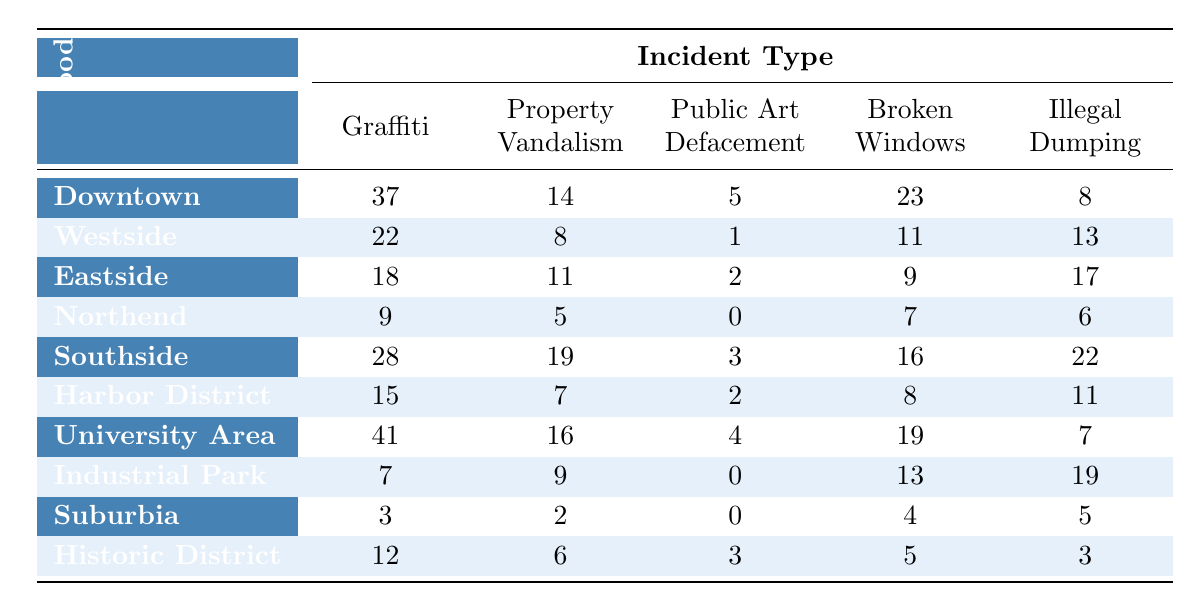What neighborhood reported the highest number of graffiti incidents? According to the table, the University Area has the highest count of graffiti incidents at 41.
Answer: 41 Which neighborhood had the fewest incidents of public art defacement? The Northend and Suburbia both reported 0 incidents of public art defacement, indicating the fewest.
Answer: Northend and Suburbia How many total incidents of property vandalism were reported in the Southside? The Southside reported 19 incidents of property vandalism as shown directly in the table.
Answer: 19 What is the total number of broken windows incidents reported across all neighborhoods? To find the total broken windows incidents, we add up the numbers from each neighborhood: 23 + 11 + 9 + 7 + 16 + 8 + 19 + 13 + 4 + 5 = 111
Answer: 111 Did the University Area have more incidents of illegal dumping than the Eastside? Yes, the University Area reported 7 incidents of illegal dumping while the Eastside reported 17.
Answer: No What is the average number of graffiti incidents reported across all neighborhoods? To find the average, we sum the graffiti incidents (37 + 22 + 18 + 9 + 28 + 15 + 41 + 7 + 3 + 12 = 192) and divide by the number of neighborhoods (10). The average is 192 / 10 = 19.2.
Answer: 19.2 Which neighborhood had the highest combined total of all types of incidents? First, we find the total incidents for each neighborhood: Downtown (37+14+5+23+8=87), Westside (22+8+1+11+13=55), Eastside (18+11+2+9+17=57), Northend (9+5+0+7+6=27), Southside (28+19+3+16+22=88), Harbor District (15+7+2+8+11=43), University Area (41+16+4+19+7=87), Industrial Park (7+9+0+13+19=48), Suburbia (3+2+0+4+5=14), Historic District (12+6+3+5+3=29). The highest combined total is in the Southside with 88 incidents.
Answer: Southside How many more incidents of illegal dumping were reported in the Industrial Park compared to the Historic District? The Industrial Park has 19 incidents of illegal dumping, while the Historic District has 3. The difference is 19 - 3 = 16.
Answer: 16 Is Southside the only neighborhood with more than 20 incidents of any type? No, Southside has more than 20 incidents in some categories, but the University Area has 41 graffiti incidents, which is also more than 20.
Answer: No Which neighborhoods had a total of less than 30 incidents for all types combined? Suburbia had a total of 14 incidents, and Northend had 27 incidents when we sum them all (Suburbia: 3 + 2 + 0 + 4 + 5 = 14; Northend: 9 + 5 + 0 + 7 + 6 = 27).
Answer: Suburbia and Northend 